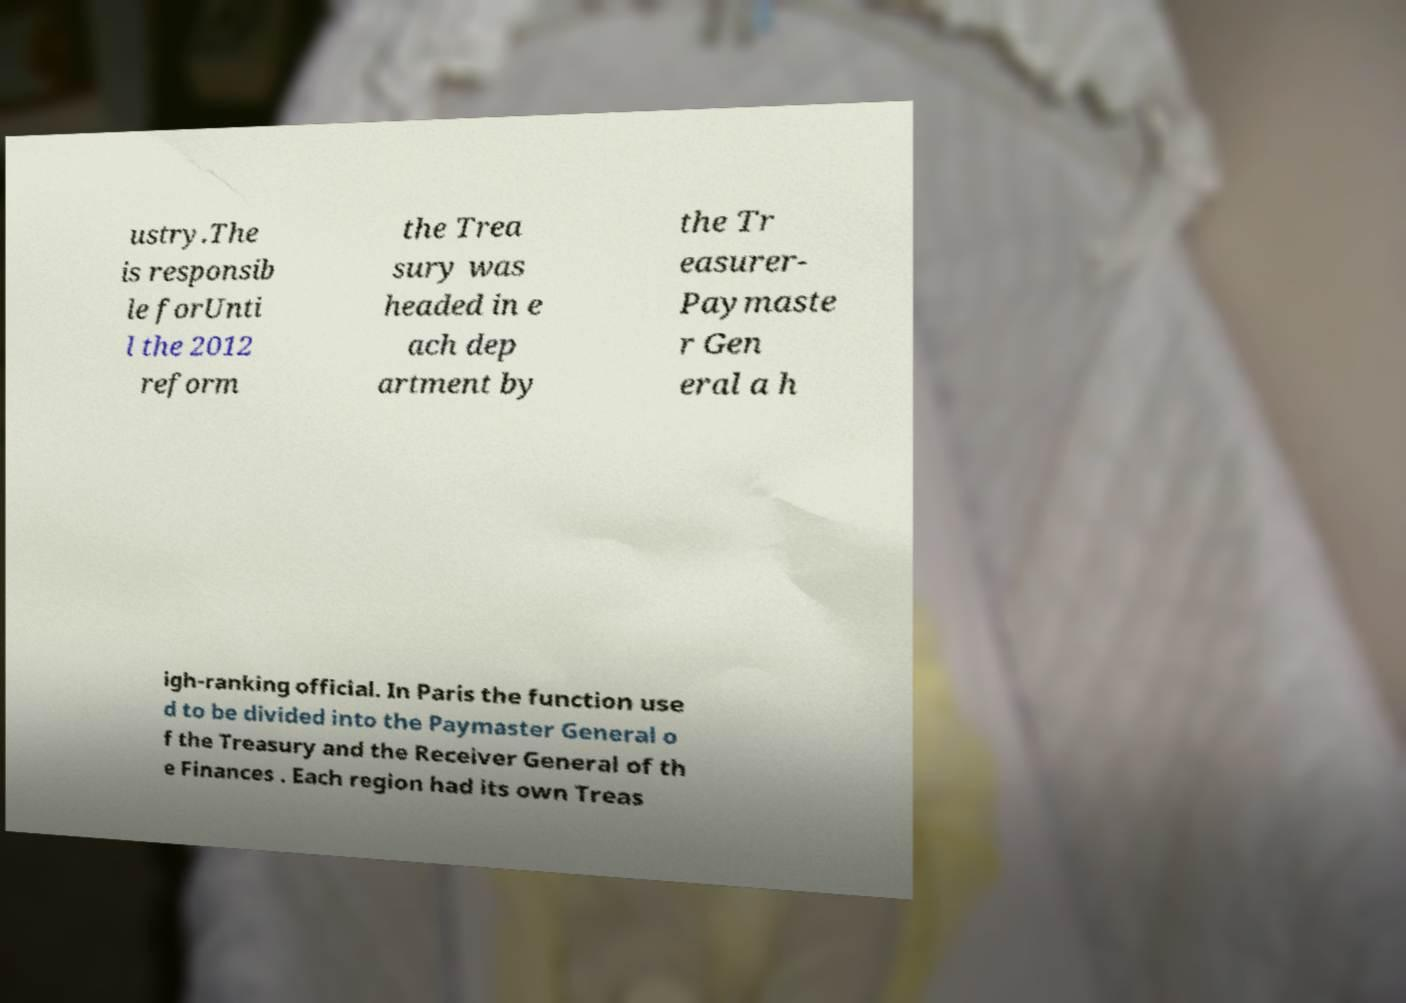There's text embedded in this image that I need extracted. Can you transcribe it verbatim? ustry.The is responsib le forUnti l the 2012 reform the Trea sury was headed in e ach dep artment by the Tr easurer- Paymaste r Gen eral a h igh-ranking official. In Paris the function use d to be divided into the Paymaster General o f the Treasury and the Receiver General of th e Finances . Each region had its own Treas 